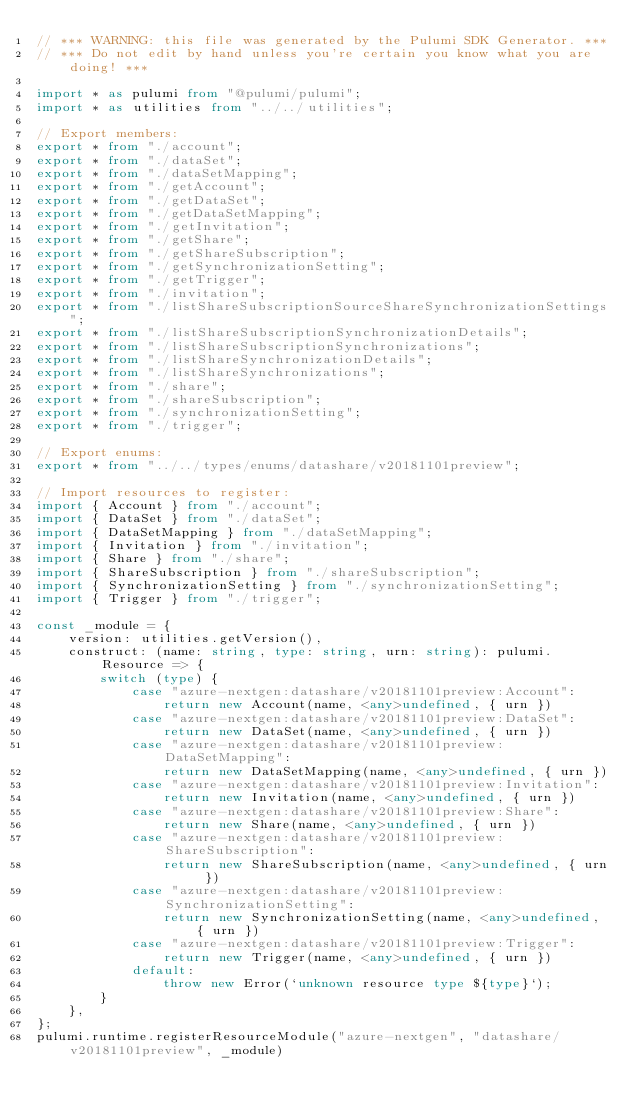<code> <loc_0><loc_0><loc_500><loc_500><_TypeScript_>// *** WARNING: this file was generated by the Pulumi SDK Generator. ***
// *** Do not edit by hand unless you're certain you know what you are doing! ***

import * as pulumi from "@pulumi/pulumi";
import * as utilities from "../../utilities";

// Export members:
export * from "./account";
export * from "./dataSet";
export * from "./dataSetMapping";
export * from "./getAccount";
export * from "./getDataSet";
export * from "./getDataSetMapping";
export * from "./getInvitation";
export * from "./getShare";
export * from "./getShareSubscription";
export * from "./getSynchronizationSetting";
export * from "./getTrigger";
export * from "./invitation";
export * from "./listShareSubscriptionSourceShareSynchronizationSettings";
export * from "./listShareSubscriptionSynchronizationDetails";
export * from "./listShareSubscriptionSynchronizations";
export * from "./listShareSynchronizationDetails";
export * from "./listShareSynchronizations";
export * from "./share";
export * from "./shareSubscription";
export * from "./synchronizationSetting";
export * from "./trigger";

// Export enums:
export * from "../../types/enums/datashare/v20181101preview";

// Import resources to register:
import { Account } from "./account";
import { DataSet } from "./dataSet";
import { DataSetMapping } from "./dataSetMapping";
import { Invitation } from "./invitation";
import { Share } from "./share";
import { ShareSubscription } from "./shareSubscription";
import { SynchronizationSetting } from "./synchronizationSetting";
import { Trigger } from "./trigger";

const _module = {
    version: utilities.getVersion(),
    construct: (name: string, type: string, urn: string): pulumi.Resource => {
        switch (type) {
            case "azure-nextgen:datashare/v20181101preview:Account":
                return new Account(name, <any>undefined, { urn })
            case "azure-nextgen:datashare/v20181101preview:DataSet":
                return new DataSet(name, <any>undefined, { urn })
            case "azure-nextgen:datashare/v20181101preview:DataSetMapping":
                return new DataSetMapping(name, <any>undefined, { urn })
            case "azure-nextgen:datashare/v20181101preview:Invitation":
                return new Invitation(name, <any>undefined, { urn })
            case "azure-nextgen:datashare/v20181101preview:Share":
                return new Share(name, <any>undefined, { urn })
            case "azure-nextgen:datashare/v20181101preview:ShareSubscription":
                return new ShareSubscription(name, <any>undefined, { urn })
            case "azure-nextgen:datashare/v20181101preview:SynchronizationSetting":
                return new SynchronizationSetting(name, <any>undefined, { urn })
            case "azure-nextgen:datashare/v20181101preview:Trigger":
                return new Trigger(name, <any>undefined, { urn })
            default:
                throw new Error(`unknown resource type ${type}`);
        }
    },
};
pulumi.runtime.registerResourceModule("azure-nextgen", "datashare/v20181101preview", _module)
</code> 